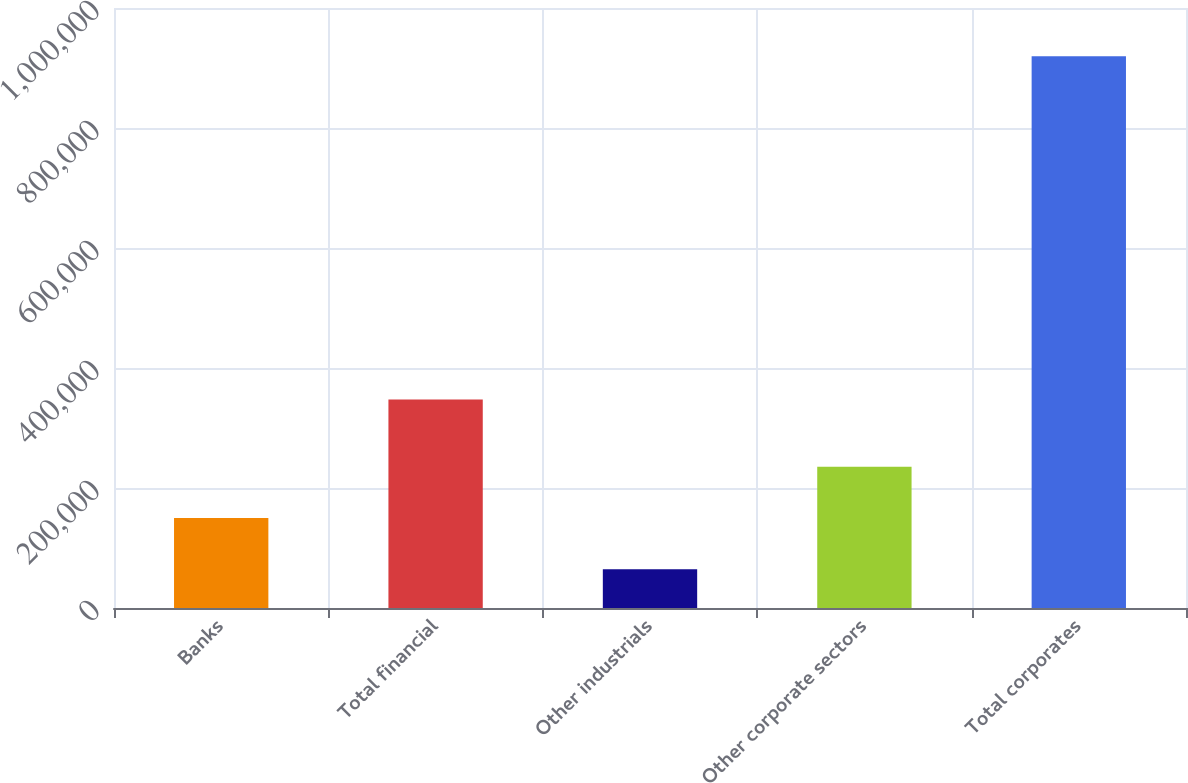<chart> <loc_0><loc_0><loc_500><loc_500><bar_chart><fcel>Banks<fcel>Total financial<fcel>Other industrials<fcel>Other corporate sectors<fcel>Total corporates<nl><fcel>150083<fcel>347550<fcel>64579<fcel>235587<fcel>919618<nl></chart> 